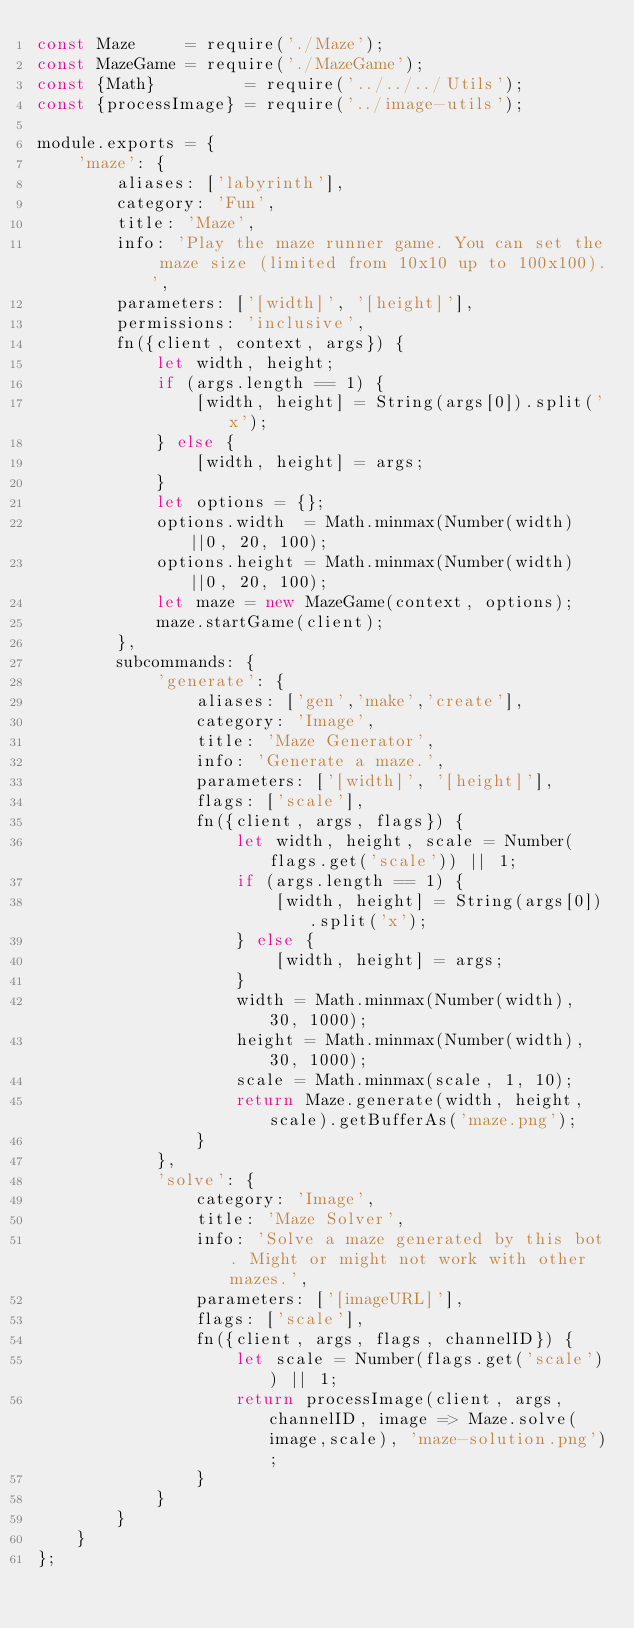<code> <loc_0><loc_0><loc_500><loc_500><_JavaScript_>const Maze     = require('./Maze');
const MazeGame = require('./MazeGame');
const {Math}         = require('../../../Utils');
const {processImage} = require('../image-utils');

module.exports = {
	'maze': {
		aliases: ['labyrinth'],
		category: 'Fun',
		title: 'Maze',
		info: 'Play the maze runner game. You can set the maze size (limited from 10x10 up to 100x100).',
		parameters: ['[width]', '[height]'],
		permissions: 'inclusive',
		fn({client, context, args}) {
			let width, height;
			if (args.length == 1) {
				[width, height] = String(args[0]).split('x');
			} else {
				[width, height] = args;
			}
			let options = {};
			options.width  = Math.minmax(Number(width)||0, 20, 100);
			options.height = Math.minmax(Number(width)||0, 20, 100);
			let maze = new MazeGame(context, options);
			maze.startGame(client);
		},
		subcommands: {
			'generate': {
				aliases: ['gen','make','create'],
				category: 'Image',
				title: 'Maze Generator',
				info: 'Generate a maze.',
				parameters: ['[width]', '[height]'],
				flags: ['scale'],
				fn({client, args, flags}) {
					let width, height, scale = Number(flags.get('scale')) || 1;
					if (args.length == 1) {
						[width, height] = String(args[0]).split('x');
					} else {
						[width, height] = args;
					}
					width = Math.minmax(Number(width), 30, 1000);
					height = Math.minmax(Number(width), 30, 1000);
					scale = Math.minmax(scale, 1, 10);
					return Maze.generate(width, height, scale).getBufferAs('maze.png');
				}
			},
			'solve': {
				category: 'Image',
				title: 'Maze Solver',
				info: 'Solve a maze generated by this bot. Might or might not work with other mazes.',
				parameters: ['[imageURL]'],
				flags: ['scale'],
				fn({client, args, flags, channelID}) {
					let scale = Number(flags.get('scale')) || 1;
					return processImage(client, args, channelID, image => Maze.solve(image,scale), 'maze-solution.png');
				}
			}
		}
	}
};
</code> 